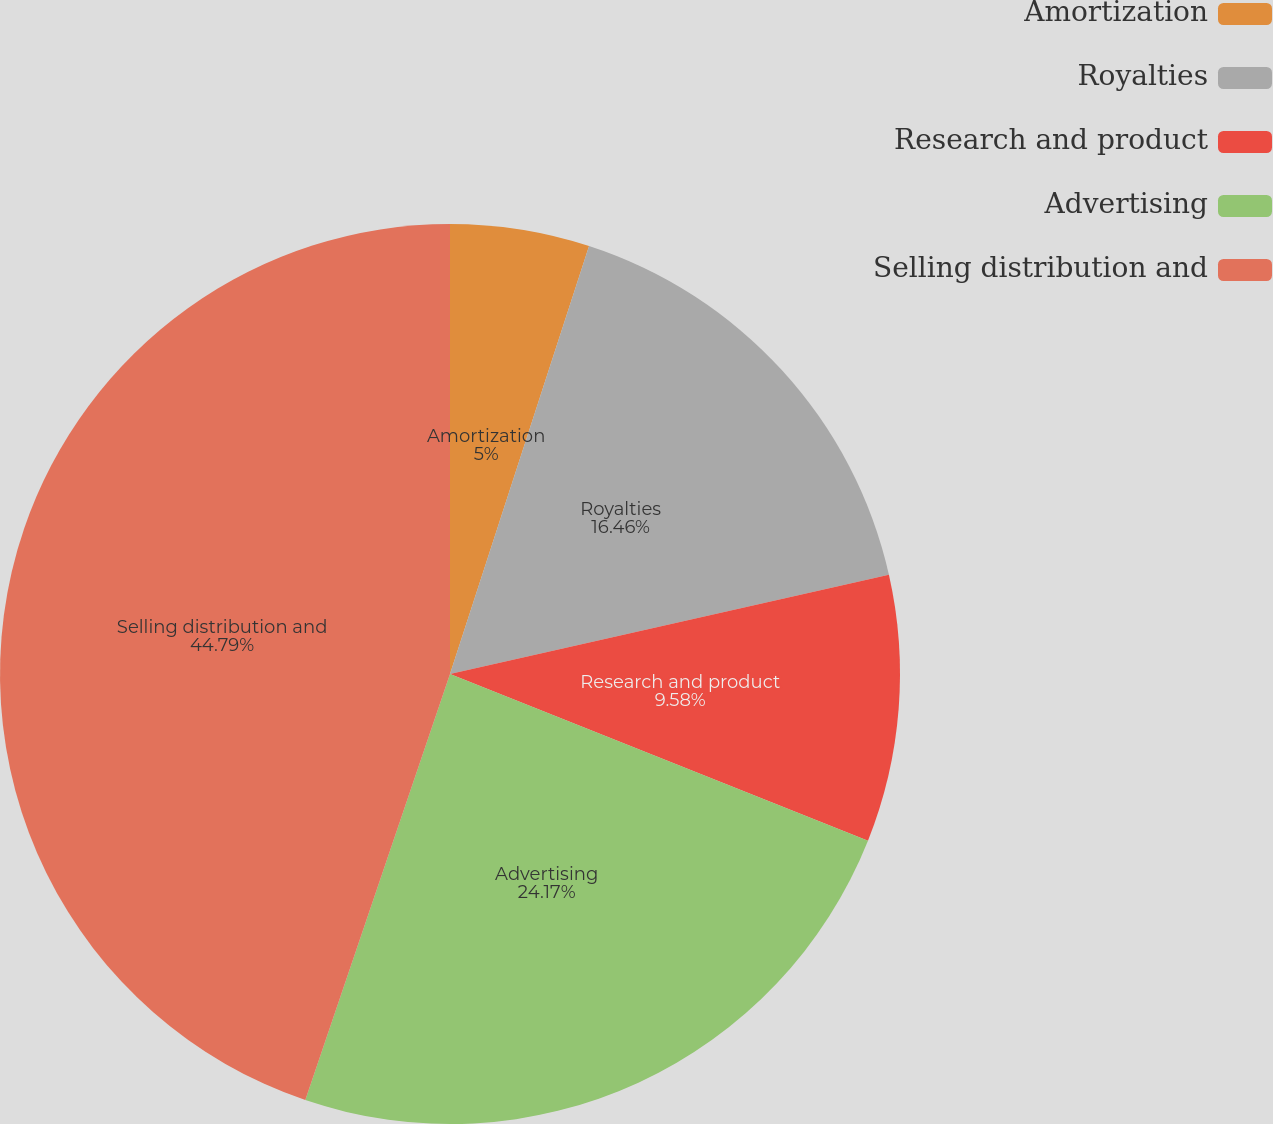Convert chart. <chart><loc_0><loc_0><loc_500><loc_500><pie_chart><fcel>Amortization<fcel>Royalties<fcel>Research and product<fcel>Advertising<fcel>Selling distribution and<nl><fcel>5.0%<fcel>16.46%<fcel>9.58%<fcel>24.17%<fcel>44.79%<nl></chart> 